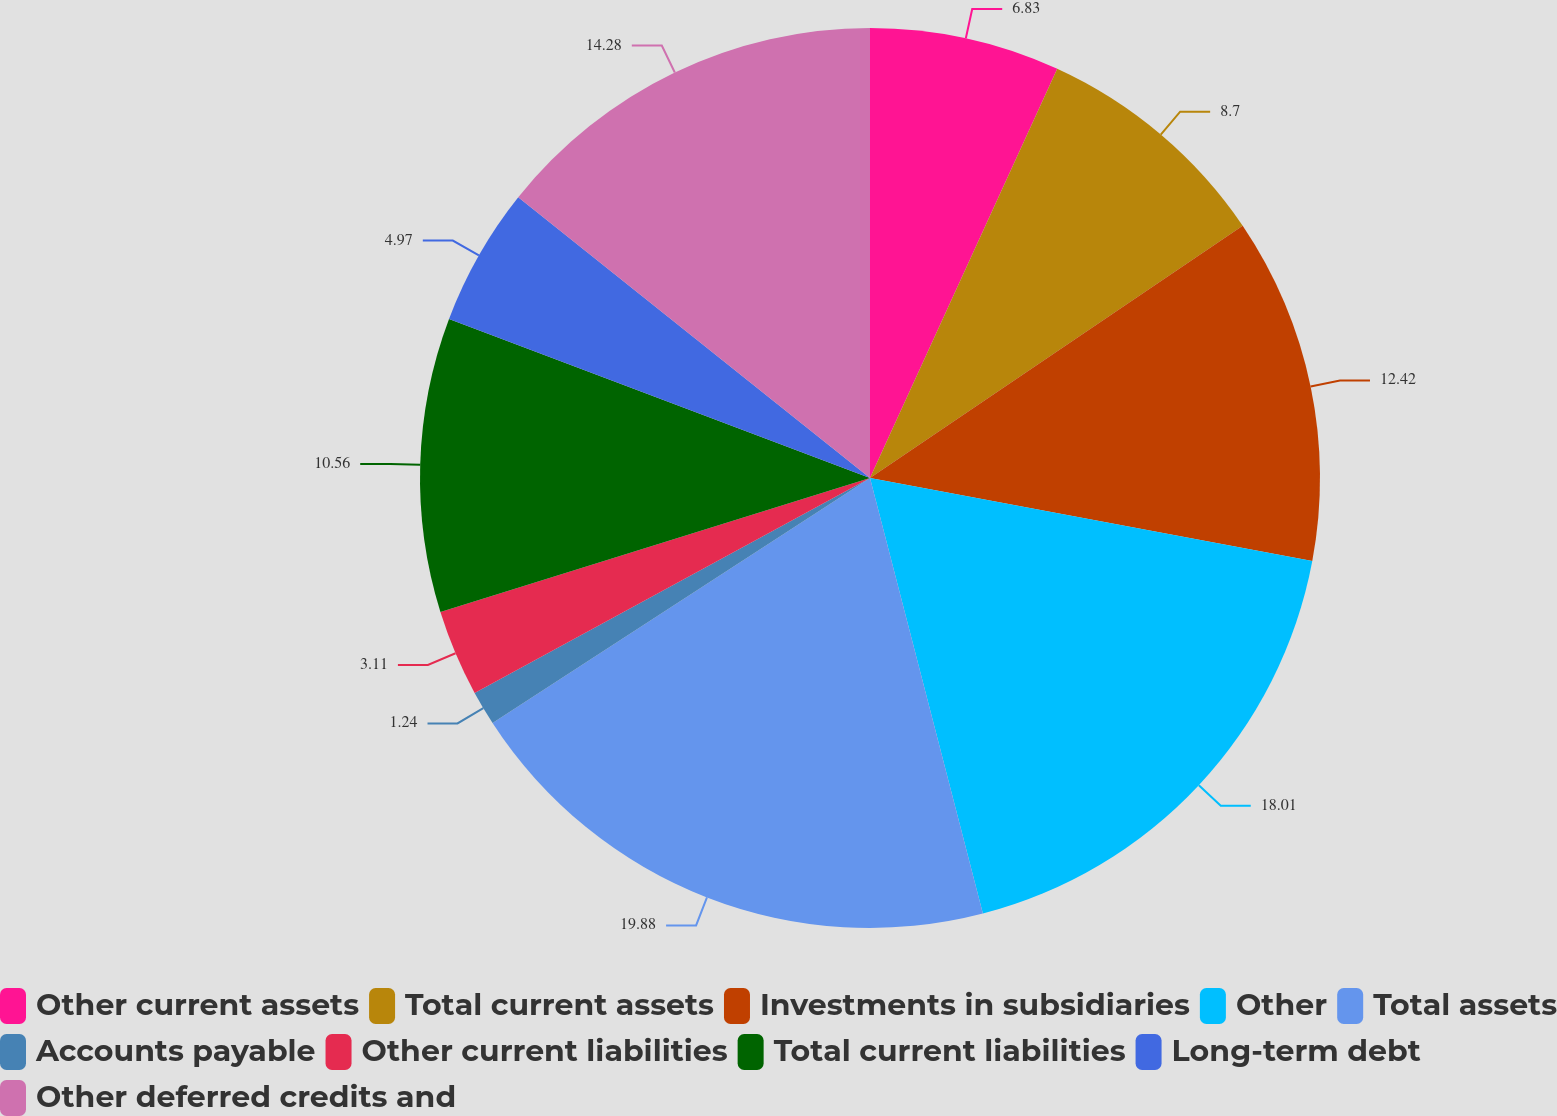Convert chart. <chart><loc_0><loc_0><loc_500><loc_500><pie_chart><fcel>Other current assets<fcel>Total current assets<fcel>Investments in subsidiaries<fcel>Other<fcel>Total assets<fcel>Accounts payable<fcel>Other current liabilities<fcel>Total current liabilities<fcel>Long-term debt<fcel>Other deferred credits and<nl><fcel>6.83%<fcel>8.7%<fcel>12.42%<fcel>18.01%<fcel>19.87%<fcel>1.24%<fcel>3.11%<fcel>10.56%<fcel>4.97%<fcel>14.28%<nl></chart> 